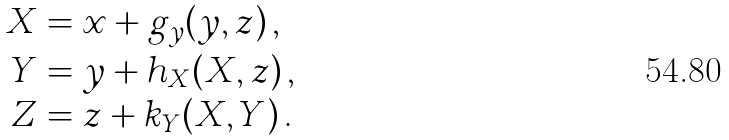Convert formula to latex. <formula><loc_0><loc_0><loc_500><loc_500>X & = x + g _ { y } ( y , z ) \, , \\ Y & = y + h _ { X } ( X , z ) \, , \\ Z & = z + k _ { Y } ( X , Y ) \, .</formula> 